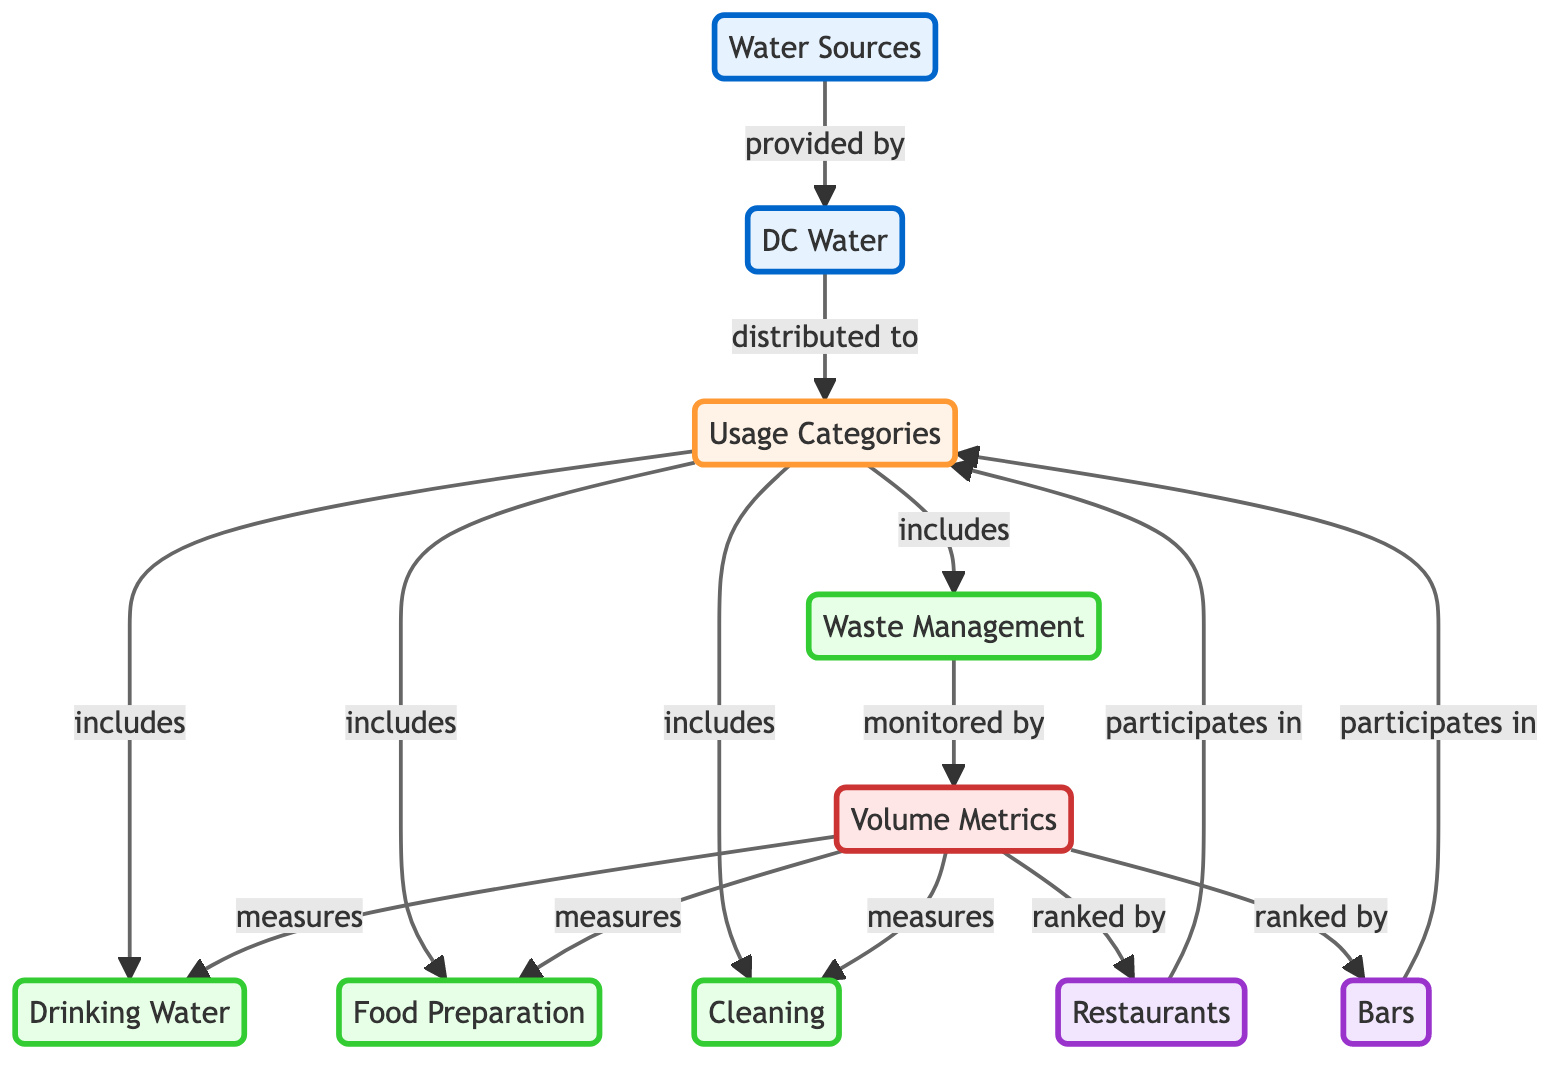What's the main water source for the establishments? The diagram indicates that the main water source is DC Water, which is a specific node representing the provider. The connection from "Water Sources" to "DC Water" describes it as the source provided to the usage categories.
Answer: DC Water How many usage categories are specified in the diagram? The diagram includes four specific nodes under "Usage Categories": Drinking Water, Food Preparation, Cleaning, and Waste Management. Counting these gives a total of four categories.
Answer: 4 Which establishment participates in the defined usage categories? Both "Restaurants" and "Bars" are indicated as the types of establishments that are participating in the usage categories as shown in the relationships leading to "Usage Categories."
Answer: Restaurants and Bars What is monitored by volume metrics according to the diagram? The node labeled "Waste Management" is connected to "Volume Metrics" with an arrow stating "monitored by," indicating that this specific aspect is being tracked through volume metrics.
Answer: Waste Management Which categories are ranked in the volume metrics section? The links originating from "Volume Metrics" lead to both "Restaurants" and "Bars," suggesting that these establishments are ranked within the volume metrics. Both are essential in measuring their respective water usage.
Answer: Restaurants and Bars Which usage category is associated with cleaning activities? The diagram clearly identifies "Cleaning" as one of the usage categories, highlighting it within the structure connected to "Usage Categories."
Answer: Cleaning How does DC Water distribute its resources according to the diagram? The arrow labeled "distributed to" shows a direct connection from "DC Water" to "Usage Categories," indicating that DC Water is the distributor of water for various uses in establishments, thus supporting multiple needs.
Answer: Usage Categories What role does "Volume Metrics" play in relation to water usage? "Volume Metrics" is depicted in the diagram as a measuring component for Drinking Water, Food Preparation, and Cleaning, alongside monitoring Waste Management, indicating a comprehensive overview of water usage across different facets.
Answer: Measures and Monitors Which source is designated as the primary water source for restaurants and bars? The diagram indicates that DC Water serves as the primary water source, as it connects directly to both the "Restaurants" and "Bars" nodes through the "Usage Categories."
Answer: DC Water 